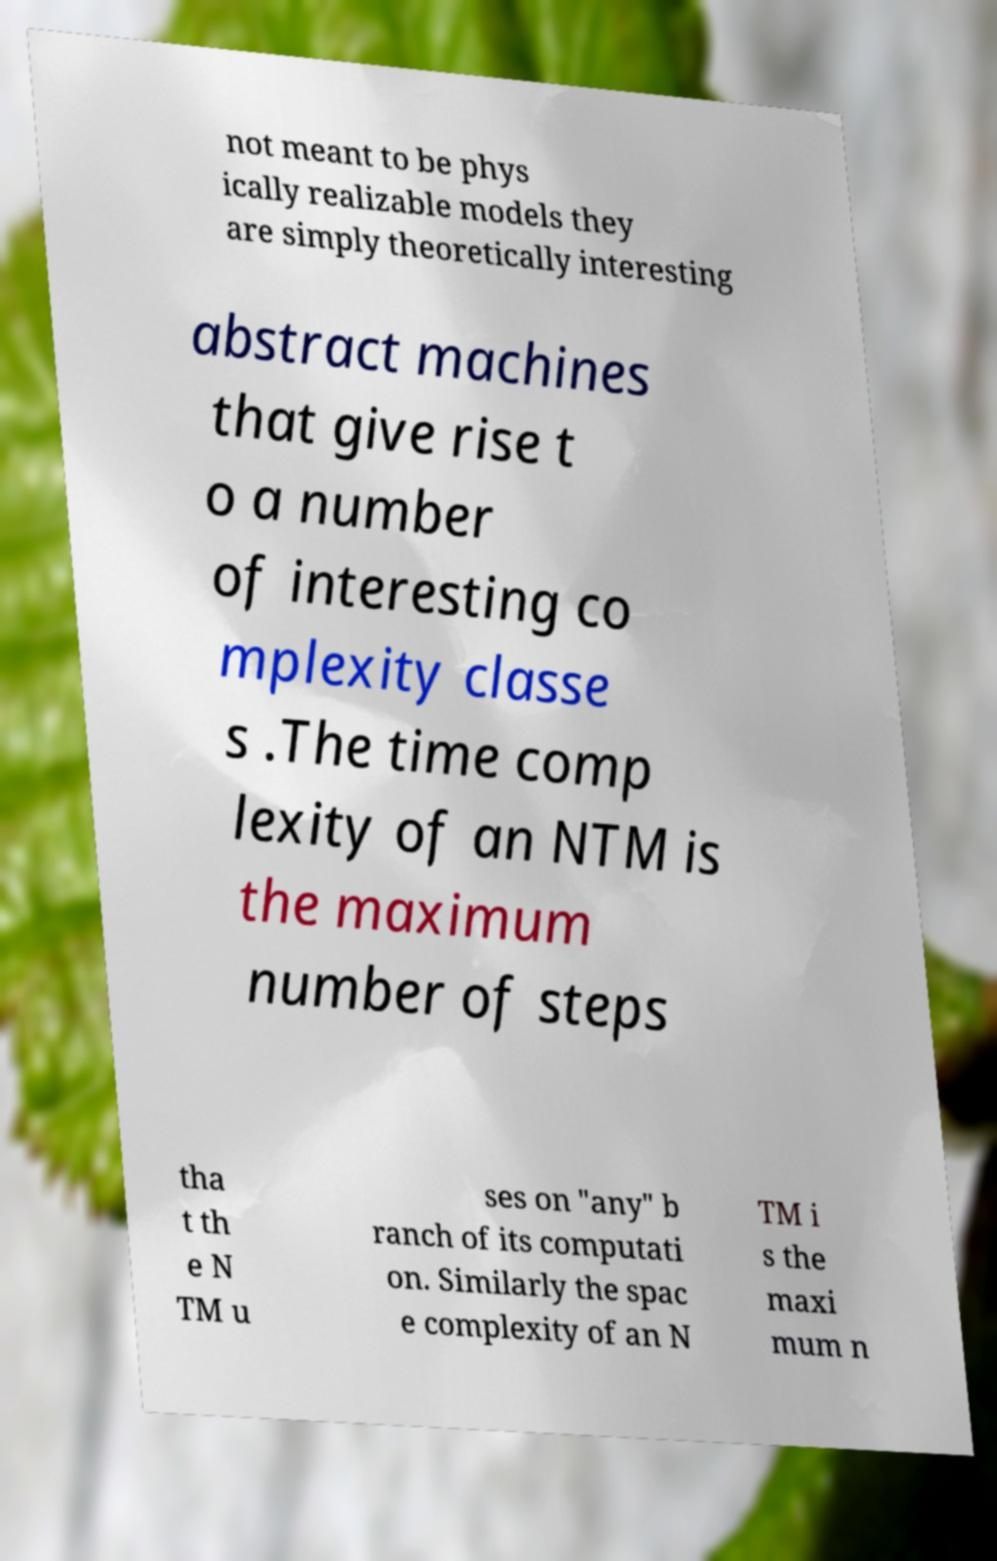Please read and relay the text visible in this image. What does it say? not meant to be phys ically realizable models they are simply theoretically interesting abstract machines that give rise t o a number of interesting co mplexity classe s .The time comp lexity of an NTM is the maximum number of steps tha t th e N TM u ses on "any" b ranch of its computati on. Similarly the spac e complexity of an N TM i s the maxi mum n 